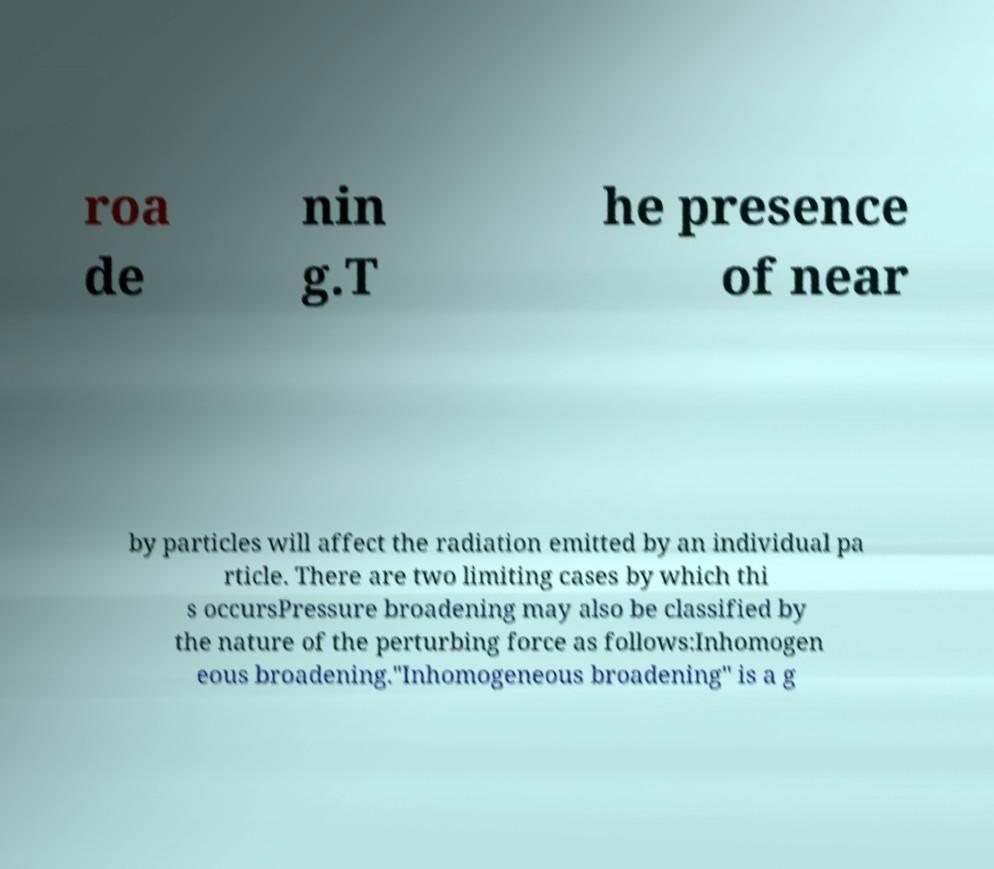Could you extract and type out the text from this image? roa de nin g.T he presence of near by particles will affect the radiation emitted by an individual pa rticle. There are two limiting cases by which thi s occursPressure broadening may also be classified by the nature of the perturbing force as follows:Inhomogen eous broadening."Inhomogeneous broadening" is a g 